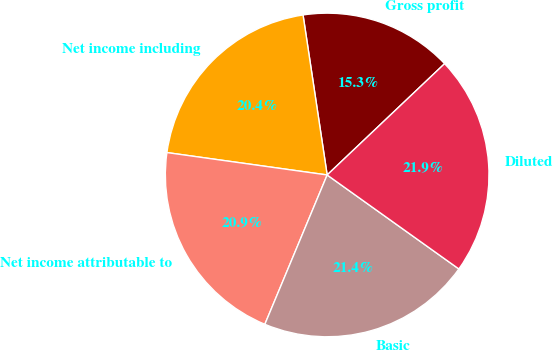Convert chart. <chart><loc_0><loc_0><loc_500><loc_500><pie_chart><fcel>Gross profit<fcel>Net income including<fcel>Net income attributable to<fcel>Basic<fcel>Diluted<nl><fcel>15.31%<fcel>20.41%<fcel>20.92%<fcel>21.43%<fcel>21.94%<nl></chart> 